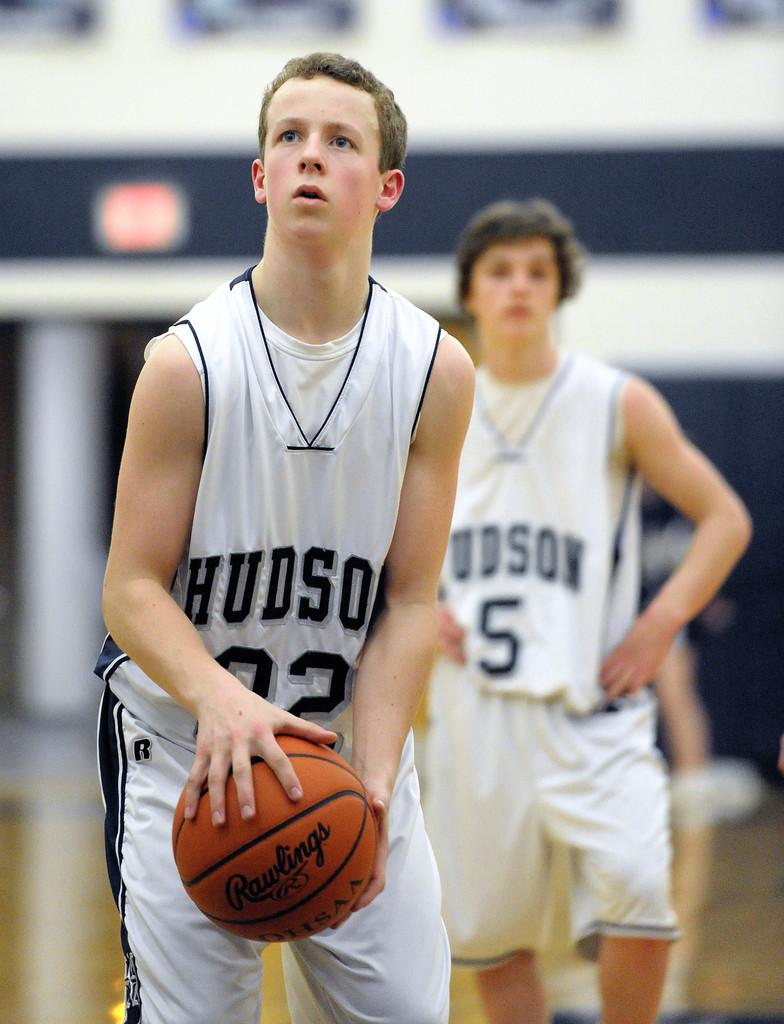What is the number of the player without the ball?
Provide a short and direct response. 5. 